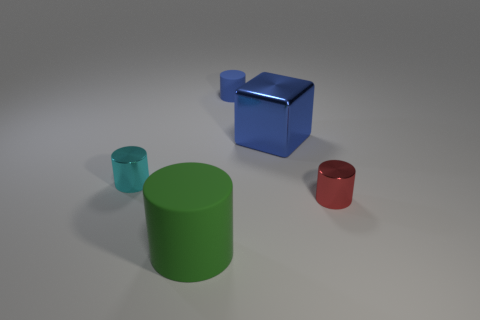Can you tell the approximate sizes of these objects? While the exact sizes are not known, relative to each other, the blue cube appears to be the largest object, followed by the green cylinder, then the red cylinder, and the smallest is the cyan cup. Without a reference object for scale, precise measurements can't be provided. Based on their sizes, what could these objects be used for? The blue cube could serve as a makeshift stool or a large storage container given its size. The green cylinder might be a decorative piece or a container, while the red cylinder could be a smaller storage or desk organizing item. Lastly, the cyan cup, given its size and shape, would be suitable for holding pens or small office supplies. 